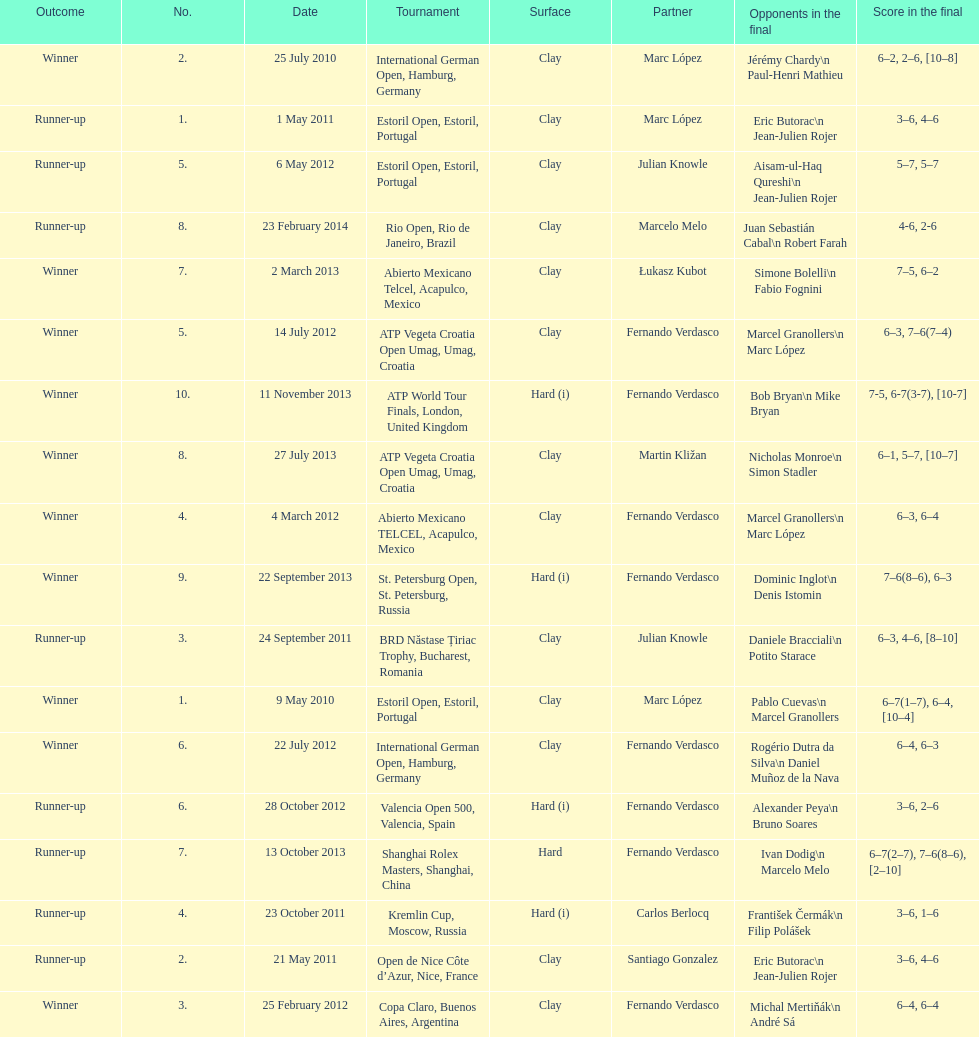What tournament was played after the kremlin cup? Copa Claro, Buenos Aires, Argentina. 